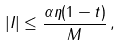<formula> <loc_0><loc_0><loc_500><loc_500>| I | \leq \frac { \alpha \eta ( 1 - t ) } { M } \, ,</formula> 